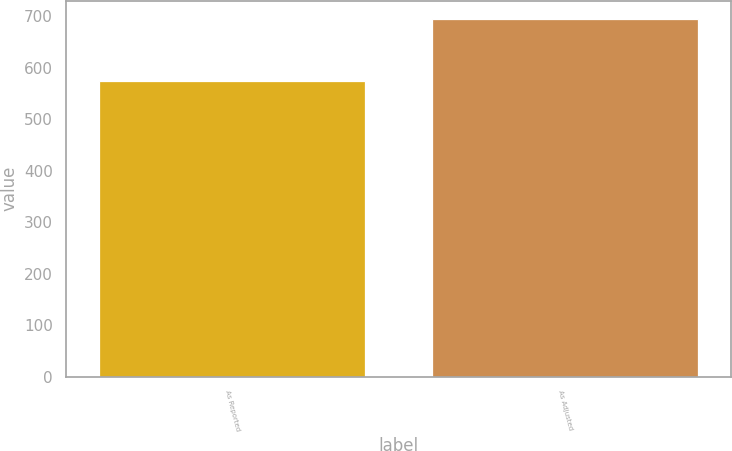<chart> <loc_0><loc_0><loc_500><loc_500><bar_chart><fcel>As Reported<fcel>As Adjusted<nl><fcel>575<fcel>695<nl></chart> 